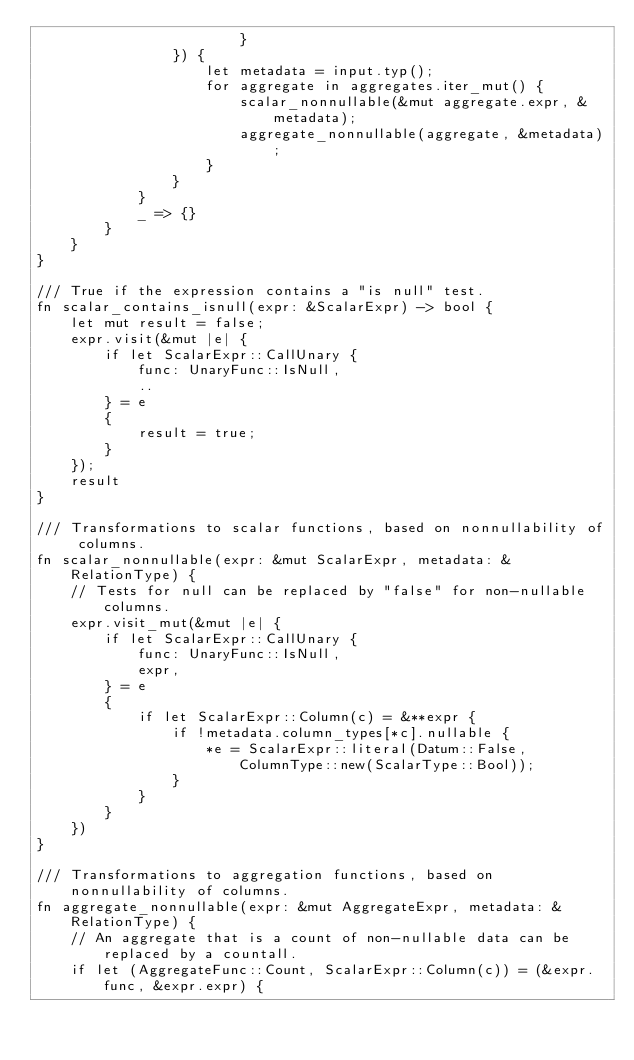<code> <loc_0><loc_0><loc_500><loc_500><_Rust_>                        }
                }) {
                    let metadata = input.typ();
                    for aggregate in aggregates.iter_mut() {
                        scalar_nonnullable(&mut aggregate.expr, &metadata);
                        aggregate_nonnullable(aggregate, &metadata);
                    }
                }
            }
            _ => {}
        }
    }
}

/// True if the expression contains a "is null" test.
fn scalar_contains_isnull(expr: &ScalarExpr) -> bool {
    let mut result = false;
    expr.visit(&mut |e| {
        if let ScalarExpr::CallUnary {
            func: UnaryFunc::IsNull,
            ..
        } = e
        {
            result = true;
        }
    });
    result
}

/// Transformations to scalar functions, based on nonnullability of columns.
fn scalar_nonnullable(expr: &mut ScalarExpr, metadata: &RelationType) {
    // Tests for null can be replaced by "false" for non-nullable columns.
    expr.visit_mut(&mut |e| {
        if let ScalarExpr::CallUnary {
            func: UnaryFunc::IsNull,
            expr,
        } = e
        {
            if let ScalarExpr::Column(c) = &**expr {
                if !metadata.column_types[*c].nullable {
                    *e = ScalarExpr::literal(Datum::False, ColumnType::new(ScalarType::Bool));
                }
            }
        }
    })
}

/// Transformations to aggregation functions, based on nonnullability of columns.
fn aggregate_nonnullable(expr: &mut AggregateExpr, metadata: &RelationType) {
    // An aggregate that is a count of non-nullable data can be replaced by a countall.
    if let (AggregateFunc::Count, ScalarExpr::Column(c)) = (&expr.func, &expr.expr) {</code> 